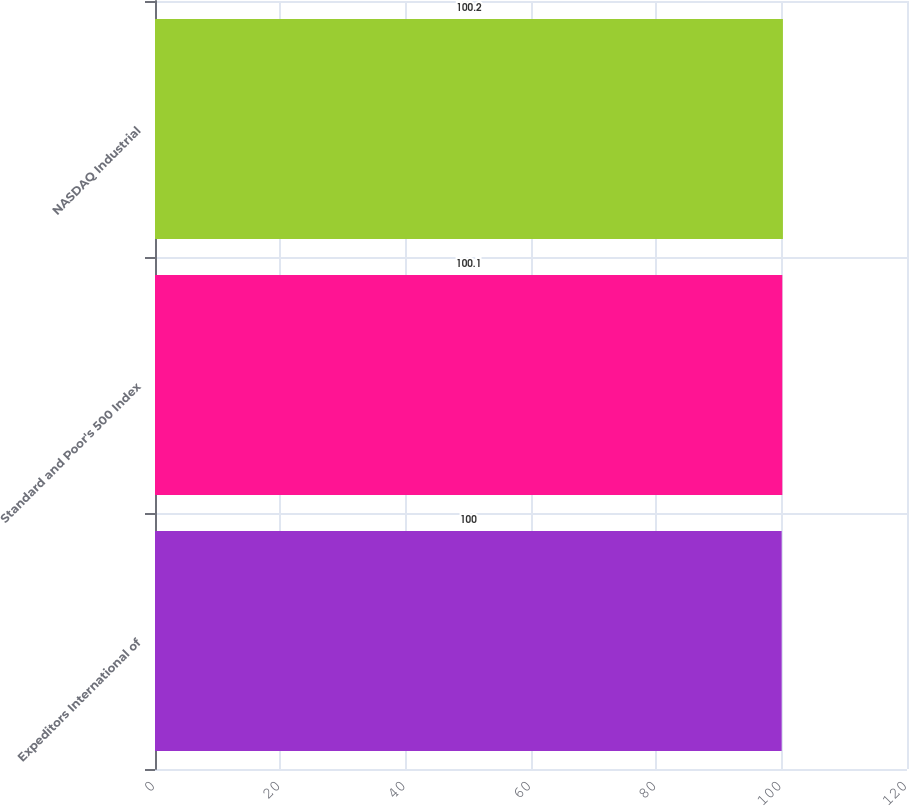<chart> <loc_0><loc_0><loc_500><loc_500><bar_chart><fcel>Expeditors International of<fcel>Standard and Poor's 500 Index<fcel>NASDAQ Industrial<nl><fcel>100<fcel>100.1<fcel>100.2<nl></chart> 